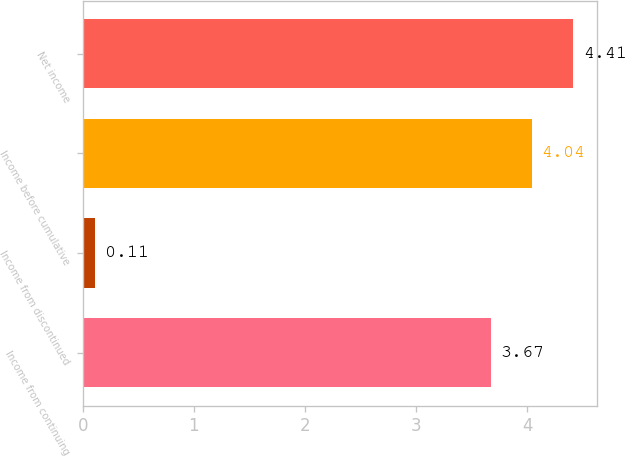Convert chart. <chart><loc_0><loc_0><loc_500><loc_500><bar_chart><fcel>Income from continuing<fcel>Income from discontinued<fcel>Income before cumulative<fcel>Net income<nl><fcel>3.67<fcel>0.11<fcel>4.04<fcel>4.41<nl></chart> 